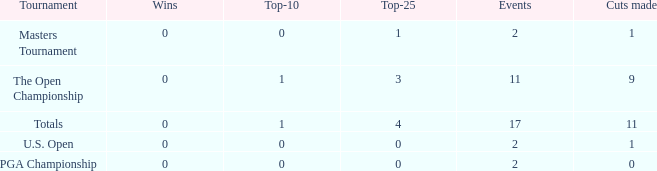Parse the full table. {'header': ['Tournament', 'Wins', 'Top-10', 'Top-25', 'Events', 'Cuts made'], 'rows': [['Masters Tournament', '0', '0', '1', '2', '1'], ['The Open Championship', '0', '1', '3', '11', '9'], ['Totals', '0', '1', '4', '17', '11'], ['U.S. Open', '0', '0', '0', '2', '1'], ['PGA Championship', '0', '0', '0', '2', '0']]} What is his highest number of top 25s when eh played over 2 events and under 0 wins? None. 